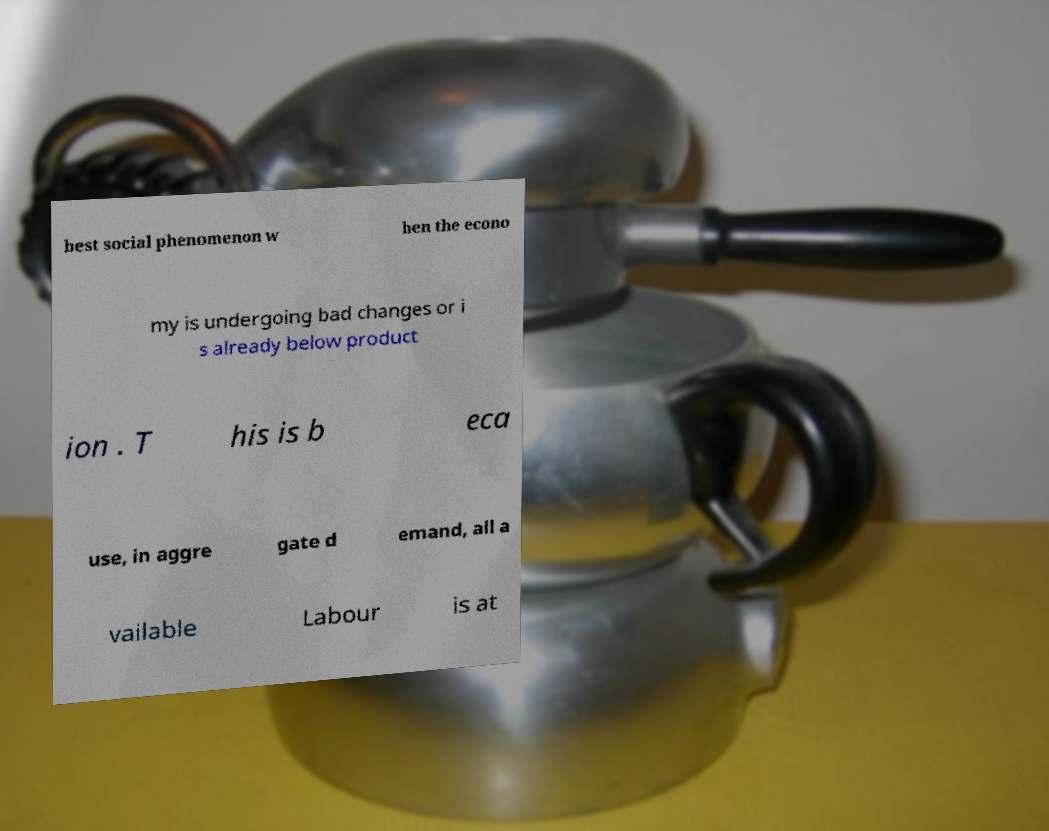Please identify and transcribe the text found in this image. best social phenomenon w hen the econo my is undergoing bad changes or i s already below product ion . T his is b eca use, in aggre gate d emand, all a vailable Labour is at 